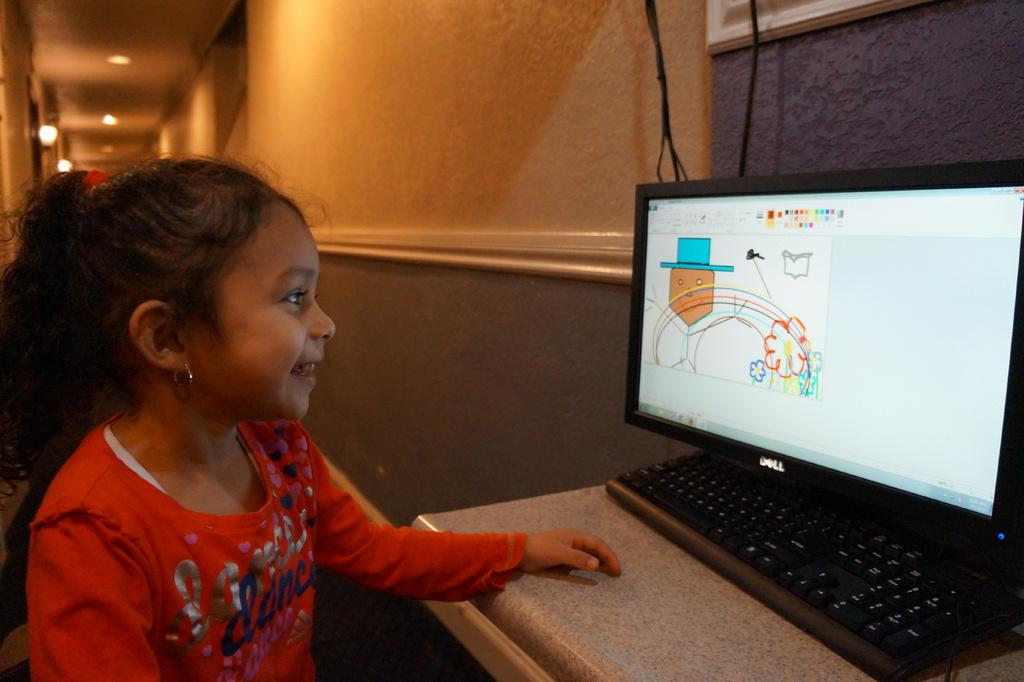<image>
Describe the image concisely. Girl making a drawing on a computer with a Dell monitor. 